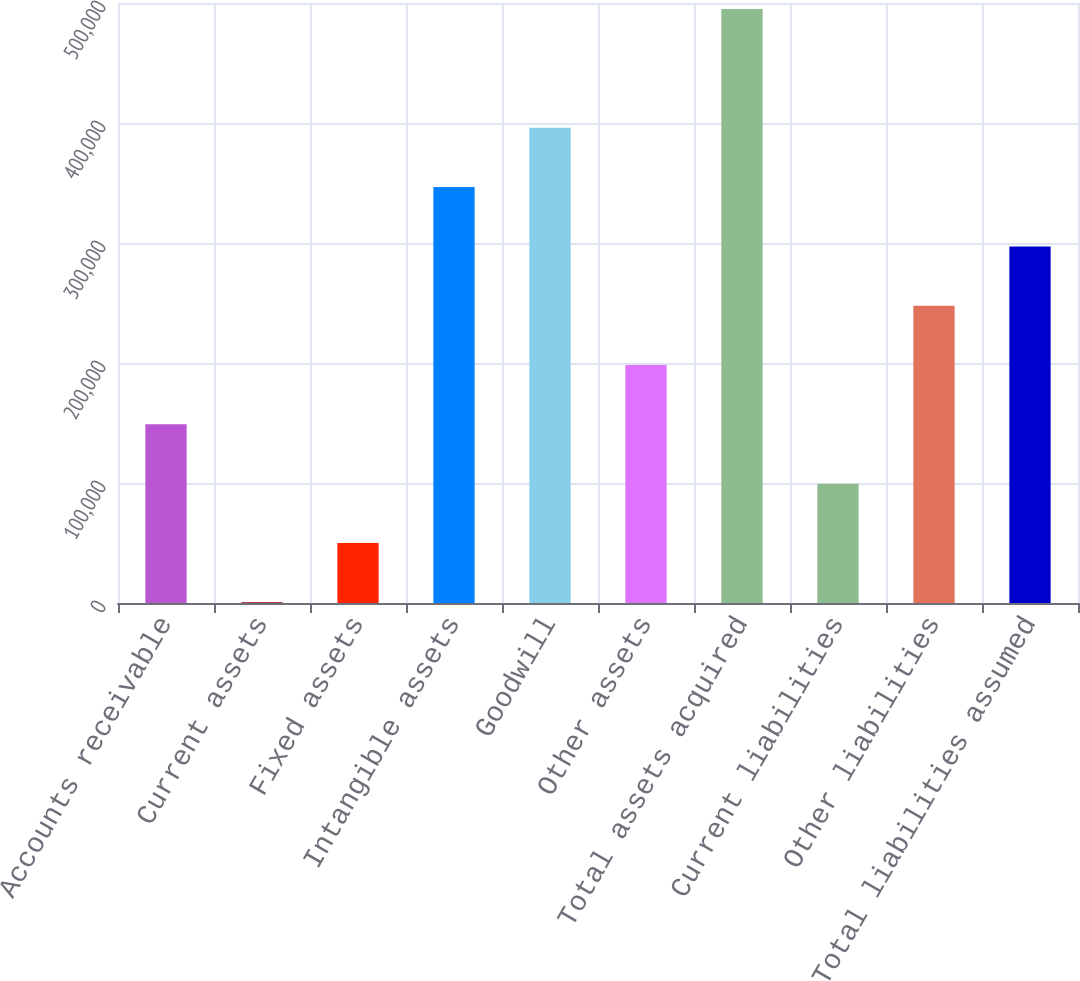Convert chart to OTSL. <chart><loc_0><loc_0><loc_500><loc_500><bar_chart><fcel>Accounts receivable<fcel>Current assets<fcel>Fixed assets<fcel>Intangible assets<fcel>Goodwill<fcel>Other assets<fcel>Total assets acquired<fcel>Current liabilities<fcel>Other liabilities<fcel>Total liabilities assumed<nl><fcel>148868<fcel>568<fcel>50001.2<fcel>346600<fcel>396034<fcel>198301<fcel>494900<fcel>99434.4<fcel>247734<fcel>297167<nl></chart> 